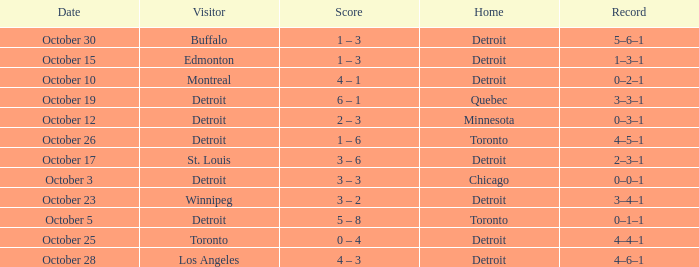Name the home with toronto visiting Detroit. 